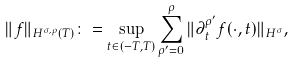<formula> <loc_0><loc_0><loc_500><loc_500>\| f \| _ { H ^ { \sigma , \rho } ( T ) } \colon = \sup _ { t \in ( - T , T ) } \sum _ { \rho ^ { \prime } = 0 } ^ { \rho } \| \partial _ { t } ^ { \rho ^ { \prime } } f ( \cdot , t ) \| _ { H ^ { \sigma } } ,</formula> 